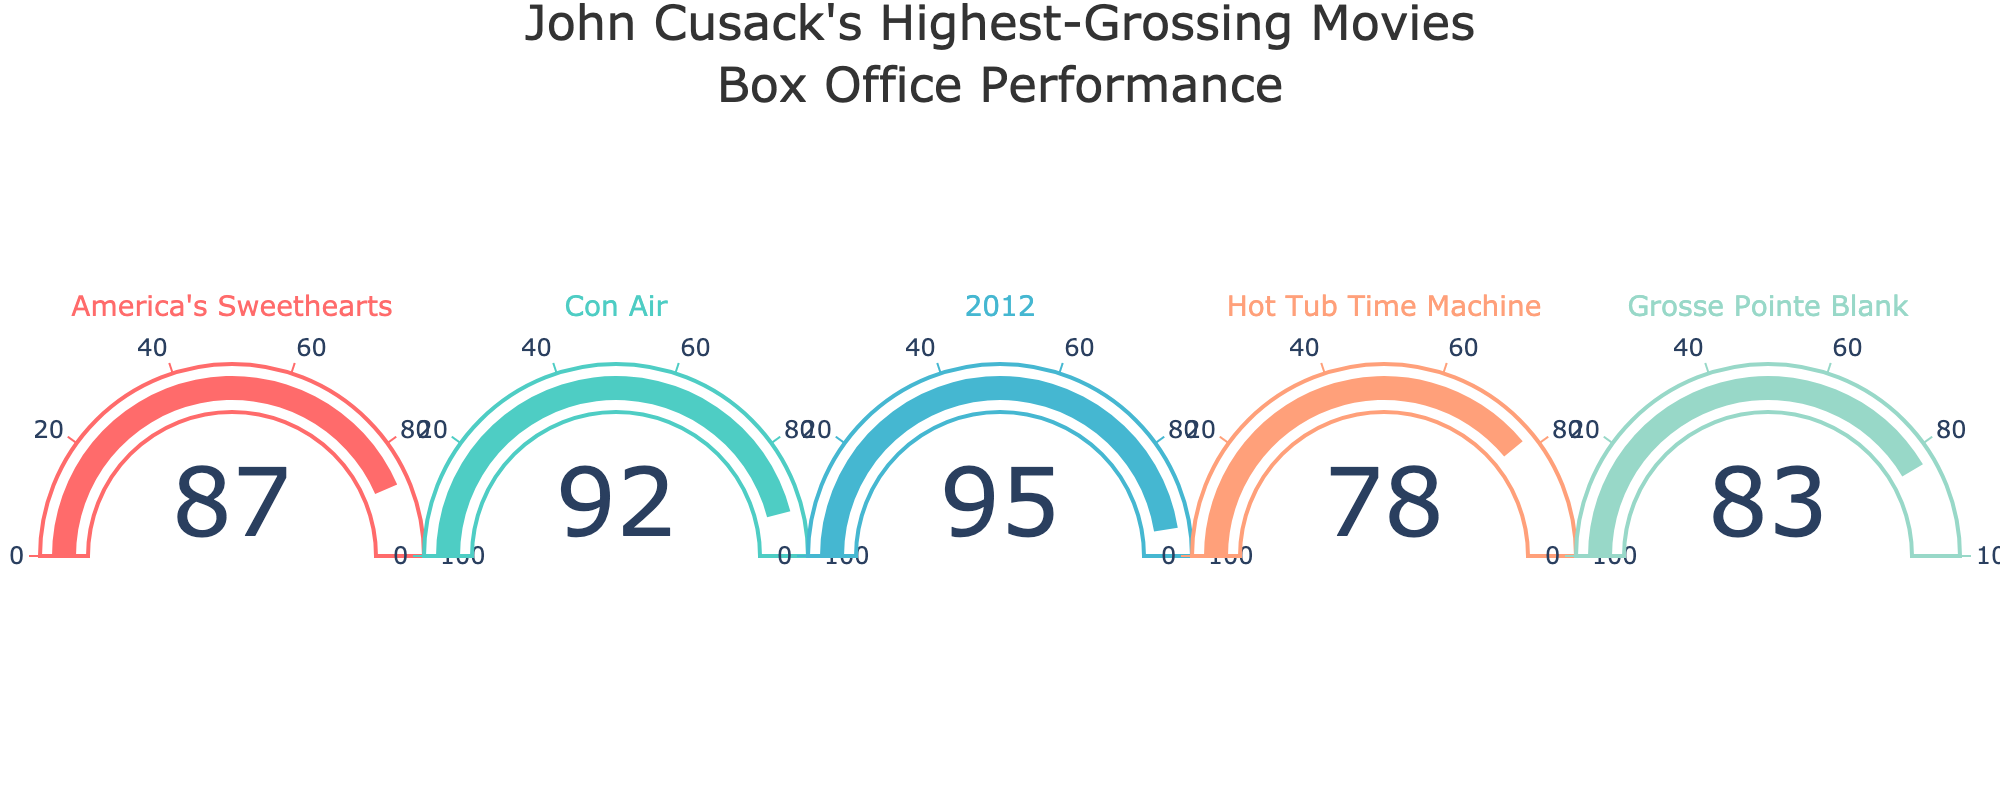what is the box office performance rating for "Con Air"? According to the gauge chart, the box office performance rating for "Con Air" is displayed as 92%.
Answer: 92% Which movie has the highest box office performance rating? By looking at the gauge chart, "2012" has the highest box office performance rating with a value of 95%.
Answer: "2012" How many movies have a box office performance rating above 80%? By examining the gauge chart, we see that "America's Sweethearts" (87%), "Con Air" (92%), "2012" (95%), and "Grosse Pointe Blank" (83%) have ratings above 80%. that's 4 movies.
Answer: 4 What is the average box office performance rating of all movies? The ratings of the five movies are 87%, 92%, 95%, 78%, and 83%. The sum of these ratings is 435%. The average is calculated as 435/5 = 87%.
Answer: 87% Which movie has the lowest box office performance rating, and what is it? From the gauge chart, "Hot Tub Time Machine" has the lowest box office performance rating of 78%.
Answer: "Hot Tub Time Machine", 78% What is the difference in box office performance rating between "2012" and "Hot Tub Time Machine"? The box office performance rating for "2012" is 95%, and for "Hot Tub Time Machine" is 78%. The difference is 95% - 78% = 17%.
Answer: 17% How do the box office performance ratings compare between "America's Sweethearts" and "Grosse Pointe Blank"? "America's Sweethearts" has a rating of 87%, while "Grosse Pointe Blank" has a rating of 83%. So, "America's Sweethearts" has a higher box office performance rating by 4%.
Answer: "America's Sweethearts" is higher by 4% Which movies have box office performance ratings between 80% and 90%? By reviewing the gauge chart, "America's Sweethearts" (87%) and "Grosse Pointe Blank" (83%) have box office performance ratings between 80% and 90%.
Answer: "America's Sweethearts" and "Grosse Pointe Blank" 